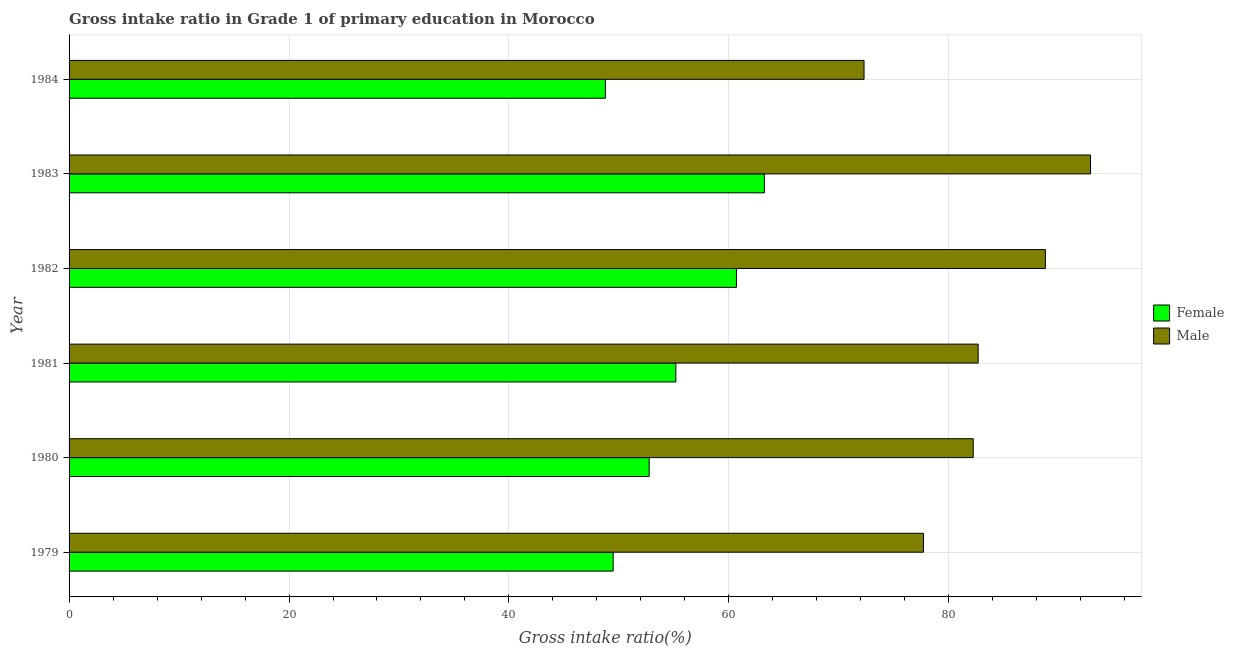How many groups of bars are there?
Your answer should be compact. 6. What is the gross intake ratio(male) in 1980?
Keep it short and to the point. 82.22. Across all years, what is the maximum gross intake ratio(male)?
Offer a terse response. 92.88. Across all years, what is the minimum gross intake ratio(male)?
Your answer should be compact. 72.29. In which year was the gross intake ratio(male) maximum?
Your response must be concise. 1983. In which year was the gross intake ratio(male) minimum?
Keep it short and to the point. 1984. What is the total gross intake ratio(female) in the graph?
Provide a short and direct response. 330.09. What is the difference between the gross intake ratio(male) in 1981 and that in 1983?
Offer a very short reply. -10.22. What is the difference between the gross intake ratio(female) in 1981 and the gross intake ratio(male) in 1980?
Give a very brief answer. -27.04. What is the average gross intake ratio(male) per year?
Keep it short and to the point. 82.76. In the year 1983, what is the difference between the gross intake ratio(male) and gross intake ratio(female)?
Give a very brief answer. 29.66. In how many years, is the gross intake ratio(male) greater than 12 %?
Offer a terse response. 6. Is the difference between the gross intake ratio(female) in 1983 and 1984 greater than the difference between the gross intake ratio(male) in 1983 and 1984?
Offer a terse response. No. What is the difference between the highest and the second highest gross intake ratio(male)?
Your response must be concise. 4.1. What is the difference between the highest and the lowest gross intake ratio(female)?
Your response must be concise. 14.46. In how many years, is the gross intake ratio(male) greater than the average gross intake ratio(male) taken over all years?
Provide a succinct answer. 2. What is the difference between two consecutive major ticks on the X-axis?
Give a very brief answer. 20. Does the graph contain any zero values?
Your answer should be very brief. No. Does the graph contain grids?
Your answer should be compact. Yes. How many legend labels are there?
Offer a very short reply. 2. What is the title of the graph?
Provide a succinct answer. Gross intake ratio in Grade 1 of primary education in Morocco. What is the label or title of the X-axis?
Provide a succinct answer. Gross intake ratio(%). What is the Gross intake ratio(%) of Female in 1979?
Keep it short and to the point. 49.48. What is the Gross intake ratio(%) of Male in 1979?
Offer a terse response. 77.7. What is the Gross intake ratio(%) of Female in 1980?
Your answer should be very brief. 52.75. What is the Gross intake ratio(%) of Male in 1980?
Offer a very short reply. 82.22. What is the Gross intake ratio(%) of Female in 1981?
Provide a succinct answer. 55.18. What is the Gross intake ratio(%) of Male in 1981?
Offer a terse response. 82.67. What is the Gross intake ratio(%) of Female in 1982?
Offer a very short reply. 60.69. What is the Gross intake ratio(%) in Male in 1982?
Provide a succinct answer. 88.78. What is the Gross intake ratio(%) of Female in 1983?
Keep it short and to the point. 63.23. What is the Gross intake ratio(%) in Male in 1983?
Provide a succinct answer. 92.88. What is the Gross intake ratio(%) of Female in 1984?
Offer a terse response. 48.77. What is the Gross intake ratio(%) in Male in 1984?
Provide a short and direct response. 72.29. Across all years, what is the maximum Gross intake ratio(%) in Female?
Ensure brevity in your answer.  63.23. Across all years, what is the maximum Gross intake ratio(%) in Male?
Your answer should be compact. 92.88. Across all years, what is the minimum Gross intake ratio(%) of Female?
Make the answer very short. 48.77. Across all years, what is the minimum Gross intake ratio(%) of Male?
Your answer should be compact. 72.29. What is the total Gross intake ratio(%) of Female in the graph?
Make the answer very short. 330.09. What is the total Gross intake ratio(%) in Male in the graph?
Give a very brief answer. 496.53. What is the difference between the Gross intake ratio(%) in Female in 1979 and that in 1980?
Give a very brief answer. -3.27. What is the difference between the Gross intake ratio(%) in Male in 1979 and that in 1980?
Keep it short and to the point. -4.52. What is the difference between the Gross intake ratio(%) of Female in 1979 and that in 1981?
Give a very brief answer. -5.7. What is the difference between the Gross intake ratio(%) of Male in 1979 and that in 1981?
Your response must be concise. -4.97. What is the difference between the Gross intake ratio(%) in Female in 1979 and that in 1982?
Your answer should be very brief. -11.21. What is the difference between the Gross intake ratio(%) in Male in 1979 and that in 1982?
Your answer should be very brief. -11.09. What is the difference between the Gross intake ratio(%) of Female in 1979 and that in 1983?
Offer a very short reply. -13.75. What is the difference between the Gross intake ratio(%) of Male in 1979 and that in 1983?
Your answer should be very brief. -15.19. What is the difference between the Gross intake ratio(%) in Female in 1979 and that in 1984?
Your answer should be compact. 0.71. What is the difference between the Gross intake ratio(%) of Male in 1979 and that in 1984?
Make the answer very short. 5.4. What is the difference between the Gross intake ratio(%) of Female in 1980 and that in 1981?
Provide a short and direct response. -2.43. What is the difference between the Gross intake ratio(%) in Male in 1980 and that in 1981?
Offer a terse response. -0.45. What is the difference between the Gross intake ratio(%) in Female in 1980 and that in 1982?
Offer a terse response. -7.94. What is the difference between the Gross intake ratio(%) of Male in 1980 and that in 1982?
Your answer should be compact. -6.56. What is the difference between the Gross intake ratio(%) in Female in 1980 and that in 1983?
Offer a very short reply. -10.48. What is the difference between the Gross intake ratio(%) in Male in 1980 and that in 1983?
Your answer should be compact. -10.67. What is the difference between the Gross intake ratio(%) in Female in 1980 and that in 1984?
Offer a very short reply. 3.98. What is the difference between the Gross intake ratio(%) of Male in 1980 and that in 1984?
Ensure brevity in your answer.  9.93. What is the difference between the Gross intake ratio(%) of Female in 1981 and that in 1982?
Provide a succinct answer. -5.51. What is the difference between the Gross intake ratio(%) in Male in 1981 and that in 1982?
Give a very brief answer. -6.11. What is the difference between the Gross intake ratio(%) in Female in 1981 and that in 1983?
Provide a short and direct response. -8.05. What is the difference between the Gross intake ratio(%) of Male in 1981 and that in 1983?
Offer a very short reply. -10.22. What is the difference between the Gross intake ratio(%) of Female in 1981 and that in 1984?
Ensure brevity in your answer.  6.41. What is the difference between the Gross intake ratio(%) of Male in 1981 and that in 1984?
Provide a succinct answer. 10.38. What is the difference between the Gross intake ratio(%) of Female in 1982 and that in 1983?
Your response must be concise. -2.54. What is the difference between the Gross intake ratio(%) of Male in 1982 and that in 1983?
Provide a short and direct response. -4.1. What is the difference between the Gross intake ratio(%) in Female in 1982 and that in 1984?
Keep it short and to the point. 11.92. What is the difference between the Gross intake ratio(%) in Male in 1982 and that in 1984?
Offer a very short reply. 16.49. What is the difference between the Gross intake ratio(%) of Female in 1983 and that in 1984?
Your response must be concise. 14.46. What is the difference between the Gross intake ratio(%) in Male in 1983 and that in 1984?
Your answer should be compact. 20.59. What is the difference between the Gross intake ratio(%) in Female in 1979 and the Gross intake ratio(%) in Male in 1980?
Offer a very short reply. -32.74. What is the difference between the Gross intake ratio(%) in Female in 1979 and the Gross intake ratio(%) in Male in 1981?
Your answer should be very brief. -33.19. What is the difference between the Gross intake ratio(%) in Female in 1979 and the Gross intake ratio(%) in Male in 1982?
Keep it short and to the point. -39.3. What is the difference between the Gross intake ratio(%) in Female in 1979 and the Gross intake ratio(%) in Male in 1983?
Provide a succinct answer. -43.41. What is the difference between the Gross intake ratio(%) of Female in 1979 and the Gross intake ratio(%) of Male in 1984?
Offer a very short reply. -22.81. What is the difference between the Gross intake ratio(%) of Female in 1980 and the Gross intake ratio(%) of Male in 1981?
Give a very brief answer. -29.92. What is the difference between the Gross intake ratio(%) of Female in 1980 and the Gross intake ratio(%) of Male in 1982?
Offer a terse response. -36.03. What is the difference between the Gross intake ratio(%) of Female in 1980 and the Gross intake ratio(%) of Male in 1983?
Offer a terse response. -40.13. What is the difference between the Gross intake ratio(%) of Female in 1980 and the Gross intake ratio(%) of Male in 1984?
Offer a very short reply. -19.54. What is the difference between the Gross intake ratio(%) of Female in 1981 and the Gross intake ratio(%) of Male in 1982?
Offer a very short reply. -33.6. What is the difference between the Gross intake ratio(%) of Female in 1981 and the Gross intake ratio(%) of Male in 1983?
Provide a short and direct response. -37.71. What is the difference between the Gross intake ratio(%) in Female in 1981 and the Gross intake ratio(%) in Male in 1984?
Your response must be concise. -17.11. What is the difference between the Gross intake ratio(%) in Female in 1982 and the Gross intake ratio(%) in Male in 1983?
Offer a terse response. -32.2. What is the difference between the Gross intake ratio(%) of Female in 1982 and the Gross intake ratio(%) of Male in 1984?
Ensure brevity in your answer.  -11.6. What is the difference between the Gross intake ratio(%) in Female in 1983 and the Gross intake ratio(%) in Male in 1984?
Offer a very short reply. -9.06. What is the average Gross intake ratio(%) of Female per year?
Offer a very short reply. 55.01. What is the average Gross intake ratio(%) of Male per year?
Provide a short and direct response. 82.76. In the year 1979, what is the difference between the Gross intake ratio(%) of Female and Gross intake ratio(%) of Male?
Your answer should be very brief. -28.22. In the year 1980, what is the difference between the Gross intake ratio(%) in Female and Gross intake ratio(%) in Male?
Keep it short and to the point. -29.47. In the year 1981, what is the difference between the Gross intake ratio(%) in Female and Gross intake ratio(%) in Male?
Make the answer very short. -27.49. In the year 1982, what is the difference between the Gross intake ratio(%) in Female and Gross intake ratio(%) in Male?
Your answer should be compact. -28.1. In the year 1983, what is the difference between the Gross intake ratio(%) of Female and Gross intake ratio(%) of Male?
Offer a terse response. -29.66. In the year 1984, what is the difference between the Gross intake ratio(%) in Female and Gross intake ratio(%) in Male?
Your answer should be compact. -23.52. What is the ratio of the Gross intake ratio(%) of Female in 1979 to that in 1980?
Offer a very short reply. 0.94. What is the ratio of the Gross intake ratio(%) of Male in 1979 to that in 1980?
Make the answer very short. 0.94. What is the ratio of the Gross intake ratio(%) in Female in 1979 to that in 1981?
Your answer should be very brief. 0.9. What is the ratio of the Gross intake ratio(%) in Male in 1979 to that in 1981?
Your answer should be compact. 0.94. What is the ratio of the Gross intake ratio(%) of Female in 1979 to that in 1982?
Ensure brevity in your answer.  0.82. What is the ratio of the Gross intake ratio(%) in Male in 1979 to that in 1982?
Provide a short and direct response. 0.88. What is the ratio of the Gross intake ratio(%) of Female in 1979 to that in 1983?
Keep it short and to the point. 0.78. What is the ratio of the Gross intake ratio(%) of Male in 1979 to that in 1983?
Make the answer very short. 0.84. What is the ratio of the Gross intake ratio(%) in Female in 1979 to that in 1984?
Your answer should be very brief. 1.01. What is the ratio of the Gross intake ratio(%) of Male in 1979 to that in 1984?
Your answer should be compact. 1.07. What is the ratio of the Gross intake ratio(%) in Female in 1980 to that in 1981?
Make the answer very short. 0.96. What is the ratio of the Gross intake ratio(%) of Female in 1980 to that in 1982?
Offer a very short reply. 0.87. What is the ratio of the Gross intake ratio(%) of Male in 1980 to that in 1982?
Provide a short and direct response. 0.93. What is the ratio of the Gross intake ratio(%) in Female in 1980 to that in 1983?
Make the answer very short. 0.83. What is the ratio of the Gross intake ratio(%) of Male in 1980 to that in 1983?
Offer a terse response. 0.89. What is the ratio of the Gross intake ratio(%) in Female in 1980 to that in 1984?
Provide a short and direct response. 1.08. What is the ratio of the Gross intake ratio(%) in Male in 1980 to that in 1984?
Offer a terse response. 1.14. What is the ratio of the Gross intake ratio(%) in Female in 1981 to that in 1982?
Keep it short and to the point. 0.91. What is the ratio of the Gross intake ratio(%) of Male in 1981 to that in 1982?
Ensure brevity in your answer.  0.93. What is the ratio of the Gross intake ratio(%) of Female in 1981 to that in 1983?
Ensure brevity in your answer.  0.87. What is the ratio of the Gross intake ratio(%) in Male in 1981 to that in 1983?
Offer a very short reply. 0.89. What is the ratio of the Gross intake ratio(%) of Female in 1981 to that in 1984?
Offer a very short reply. 1.13. What is the ratio of the Gross intake ratio(%) in Male in 1981 to that in 1984?
Make the answer very short. 1.14. What is the ratio of the Gross intake ratio(%) in Female in 1982 to that in 1983?
Provide a succinct answer. 0.96. What is the ratio of the Gross intake ratio(%) of Male in 1982 to that in 1983?
Offer a very short reply. 0.96. What is the ratio of the Gross intake ratio(%) in Female in 1982 to that in 1984?
Ensure brevity in your answer.  1.24. What is the ratio of the Gross intake ratio(%) of Male in 1982 to that in 1984?
Offer a very short reply. 1.23. What is the ratio of the Gross intake ratio(%) in Female in 1983 to that in 1984?
Your answer should be very brief. 1.3. What is the ratio of the Gross intake ratio(%) in Male in 1983 to that in 1984?
Provide a succinct answer. 1.28. What is the difference between the highest and the second highest Gross intake ratio(%) in Female?
Your response must be concise. 2.54. What is the difference between the highest and the second highest Gross intake ratio(%) of Male?
Offer a terse response. 4.1. What is the difference between the highest and the lowest Gross intake ratio(%) of Female?
Ensure brevity in your answer.  14.46. What is the difference between the highest and the lowest Gross intake ratio(%) of Male?
Offer a terse response. 20.59. 